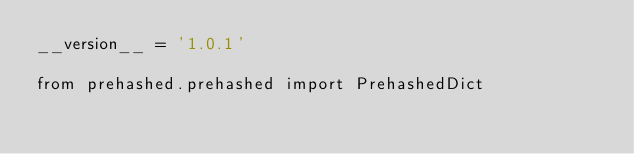Convert code to text. <code><loc_0><loc_0><loc_500><loc_500><_Python_>__version__ = '1.0.1'

from prehashed.prehashed import PrehashedDict
</code> 